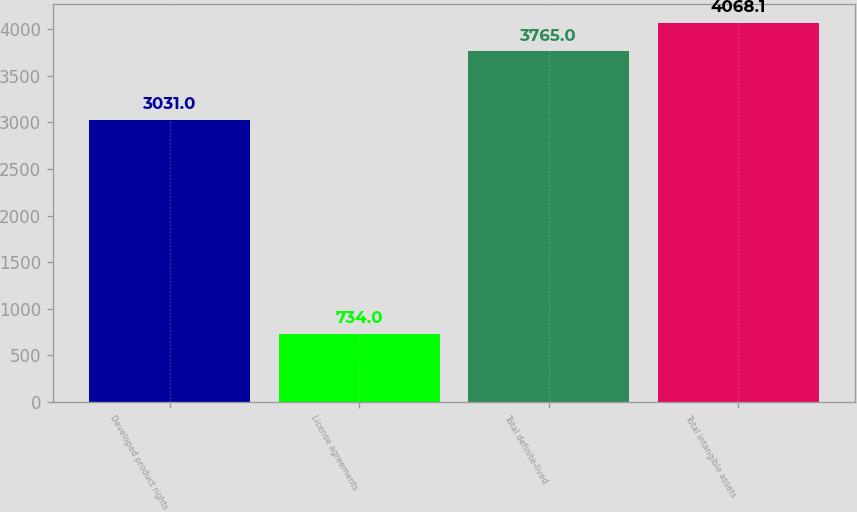Convert chart. <chart><loc_0><loc_0><loc_500><loc_500><bar_chart><fcel>Developed product rights<fcel>License agreements<fcel>Total definite-lived<fcel>Total intangible assets<nl><fcel>3031<fcel>734<fcel>3765<fcel>4068.1<nl></chart> 